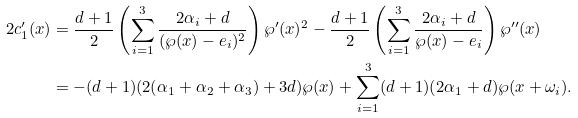Convert formula to latex. <formula><loc_0><loc_0><loc_500><loc_500>2 c ^ { \prime } _ { 1 } ( x ) & = \frac { d + 1 } { 2 } \left ( \sum _ { i = 1 } ^ { 3 } \frac { 2 \alpha _ { i } + d } { ( \wp ( x ) - e _ { i } ) ^ { 2 } } \right ) \wp ^ { \prime } ( x ) ^ { 2 } - \frac { d + 1 } { 2 } \left ( \sum _ { i = 1 } ^ { 3 } \frac { 2 \alpha _ { i } + d } { \wp ( x ) - e _ { i } } \right ) \wp ^ { \prime \prime } ( x ) \\ & = - ( d + 1 ) ( 2 ( \alpha _ { 1 } + \alpha _ { 2 } + \alpha _ { 3 } ) + 3 d ) \wp ( x ) + \sum _ { i = 1 } ^ { 3 } ( d + 1 ) ( 2 \alpha _ { 1 } + d ) \wp ( x + \omega _ { i } ) .</formula> 